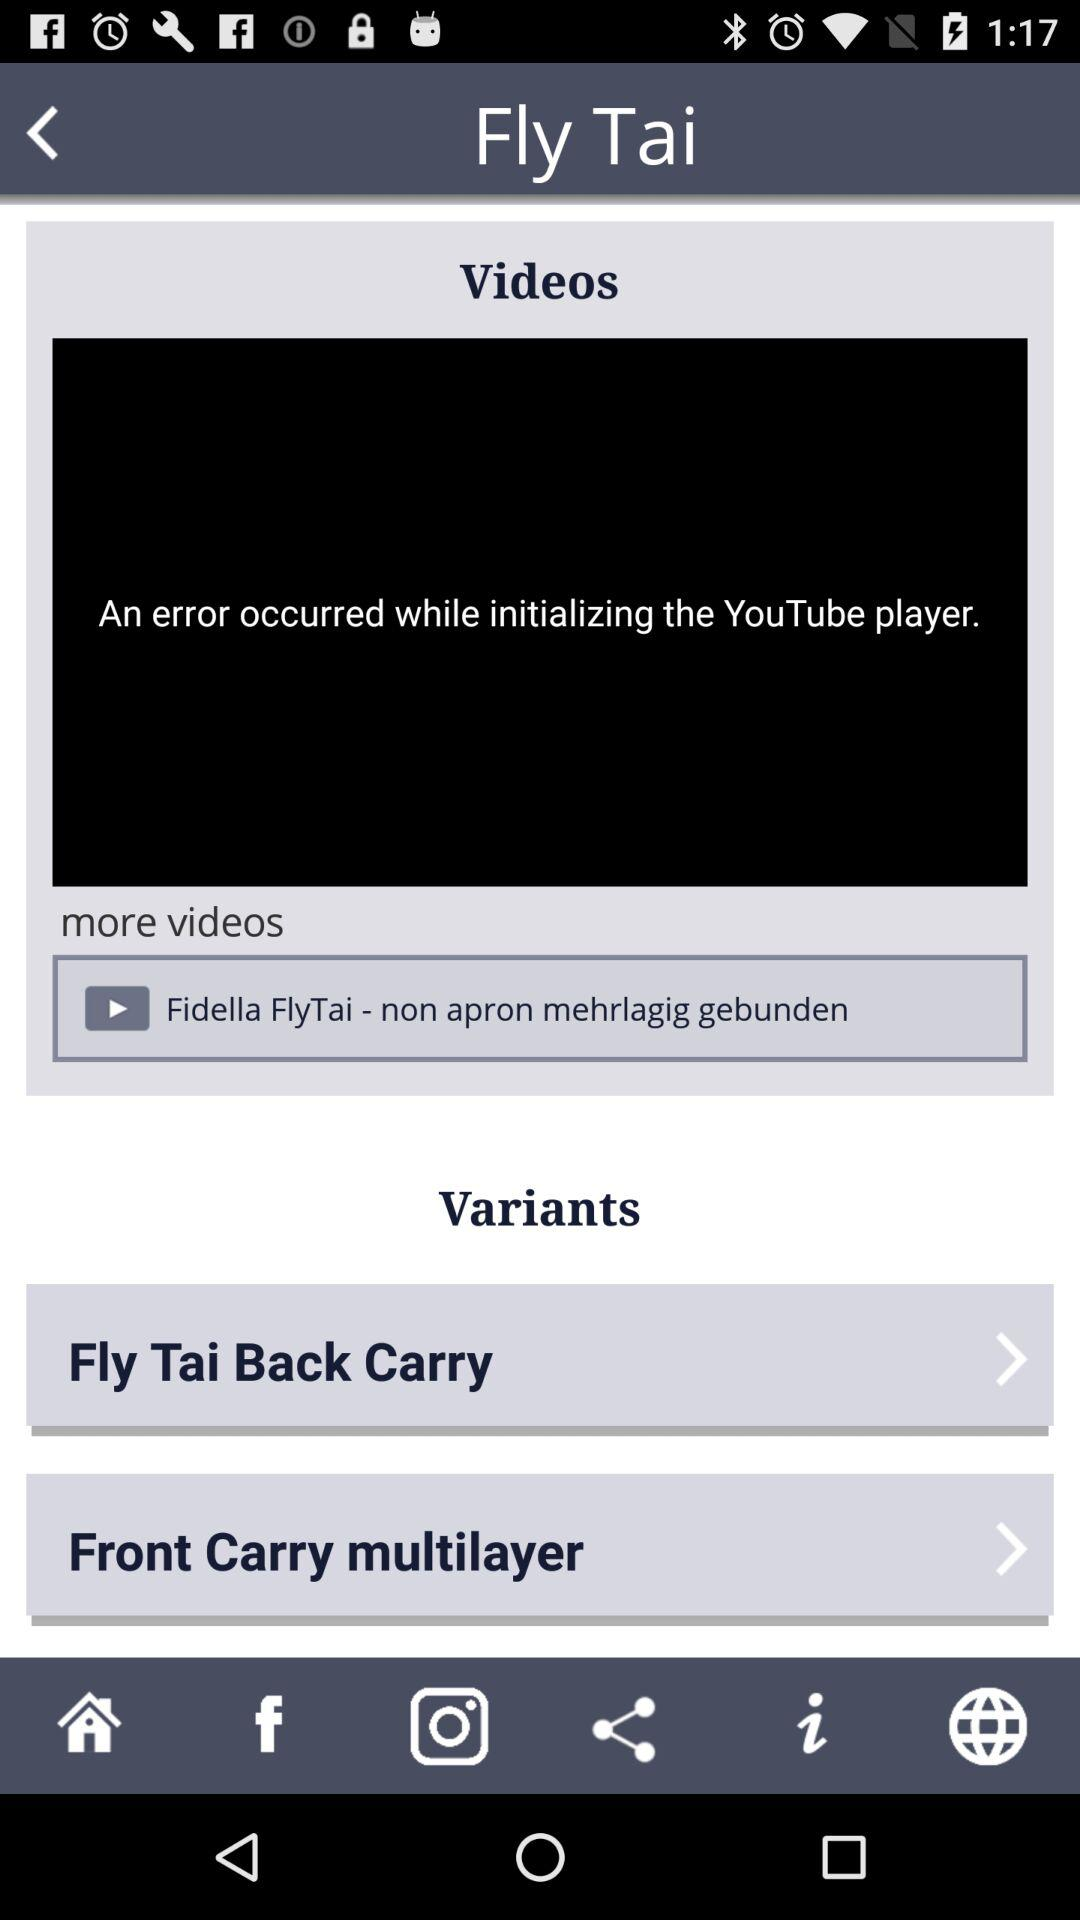What are the different options in "Variants"? The different options in "Variants" are "Fly Tai Back Carry" and "Front Carry multilayer". 